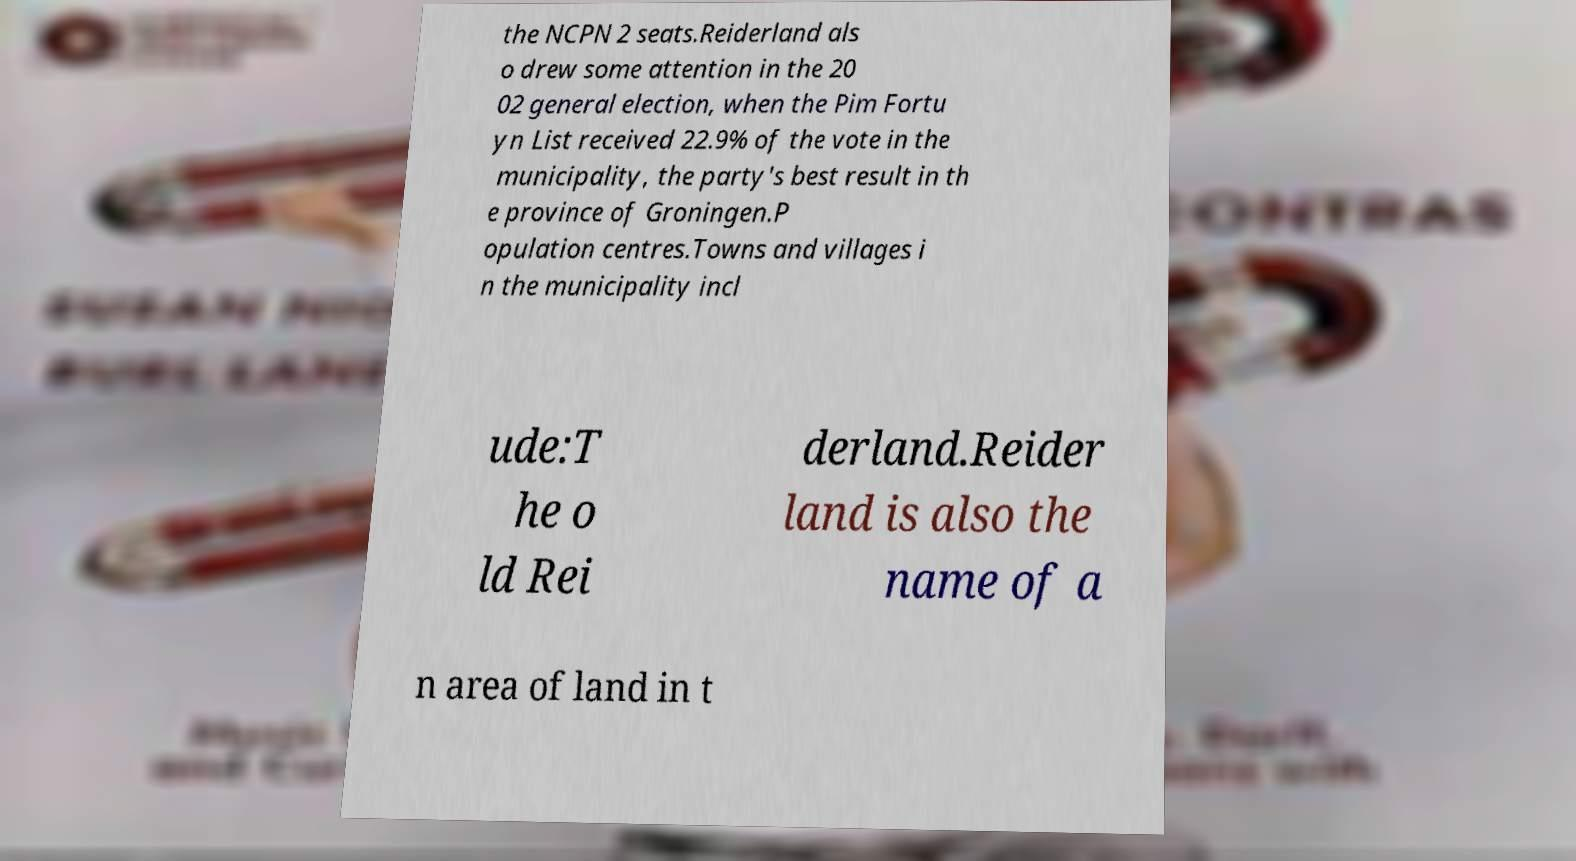Can you read and provide the text displayed in the image?This photo seems to have some interesting text. Can you extract and type it out for me? the NCPN 2 seats.Reiderland als o drew some attention in the 20 02 general election, when the Pim Fortu yn List received 22.9% of the vote in the municipality, the party's best result in th e province of Groningen.P opulation centres.Towns and villages i n the municipality incl ude:T he o ld Rei derland.Reider land is also the name of a n area of land in t 